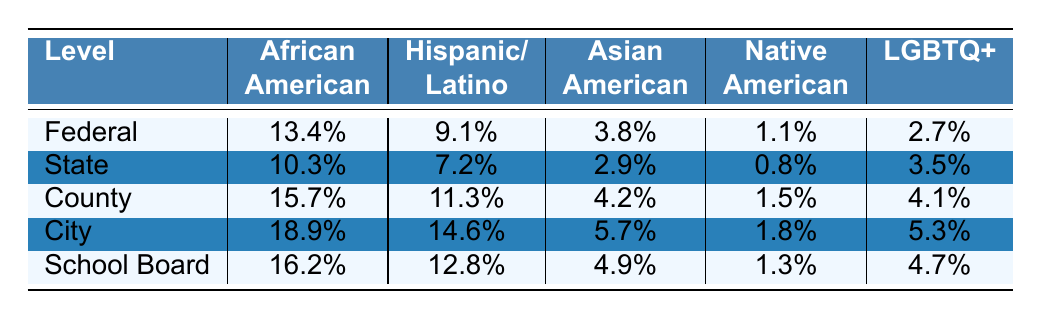What is the percentage of African American representation at the City level? The table shows that the percentage for African American representation at the City level is listed directly as 18.9%.
Answer: 18.9% Which minority group has the highest representation at the County level? By examining the values at the County level, African American representation is 15.7%, Hispanic/Latino is 11.3%, Asian American is 4.2%, Native American is 1.5%, and LGBTQ+ is 4.1%. The highest value is 15.7% for African American.
Answer: African American What is the difference in representation between Hispanic/Latino at Federal and State levels? The values for Hispanic/Latino representation are 9.1% at the Federal level and 7.2% at the State level. Subtracting these gives 9.1% - 7.2% = 1.9%.
Answer: 1.9% What is the average percentage of LGBTQ+ representation across all levels? The percentages for LGBTQ+ representation are 2.7%, 3.5%, 4.1%, 5.3%, and 4.7%. Adding these gives 2.7 + 3.5 + 4.1 + 5.3 + 4.7 = 20.3%, and dividing by 5 results in an average of 20.3% / 5 = 4.06%.
Answer: 4.06% Is the representation of Native Americans higher at the County level compared to the State level? The County representation for Native Americans is 1.5% while the State representation is 0.8%. Since 1.5% > 0.8%, the answer is yes.
Answer: Yes Which level has the highest overall representation for Hispanic/Latino minority group? By checking the table, the highest percentage for Hispanic/Latino occurs at the City level with 14.6%.
Answer: City What is the total percentage of Asian American representation across all levels? The percentages for Asian American representation at each level are 3.8%, 2.9%, 4.2%, 5.7%, and 4.9%. Summing these gives 3.8 + 2.9 + 4.2 + 5.7 + 4.9 = 21.5%.
Answer: 21.5% At which level does the representation of minorities lag significantly compared to others? When looking at the percentages, the State level shows the lowest numbers across most categories compared to Federal, County, City, and School Board. This suggests the State level lags significantly in representation.
Answer: State 